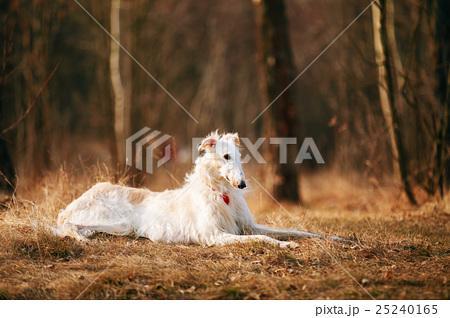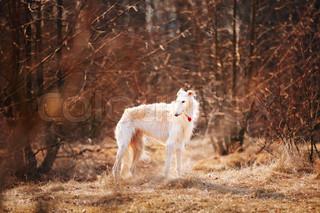The first image is the image on the left, the second image is the image on the right. Assess this claim about the two images: "Two dogs are laying down.". Correct or not? Answer yes or no. No. The first image is the image on the left, the second image is the image on the right. Considering the images on both sides, is "The left and right image contains the same number of dogs with their bodies facing right." valid? Answer yes or no. Yes. 